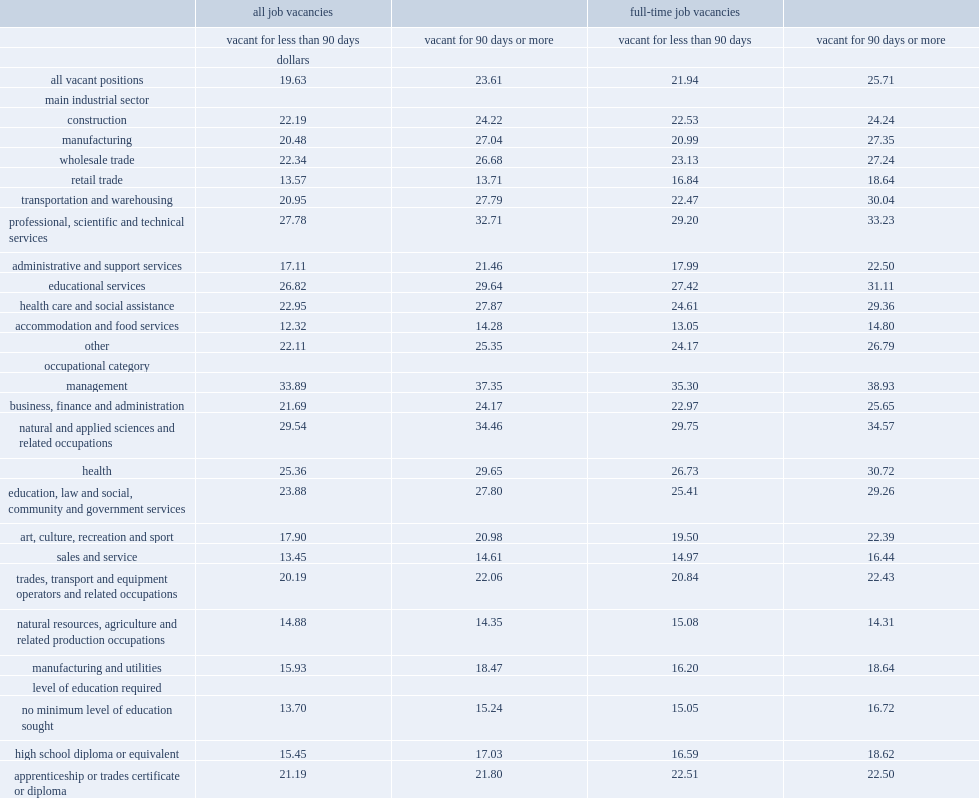In 2016, what is the difference between employers were willing to pay $23.61 per hour on average to fill long-term vacancies and those with $19.63 for positions vacant for less than 90 days? 0.202751. In 2016, list top two vacant positions among main industrial sectors that have the largest gaps between long-term job vacancies and other job vacancies. Transportation and warehousing manufacturing. For having the largest gaps between long-term job vacancies and other job vacancies, which sectors ranked fourth and sixth, respectively? Health care and social assistance professional, scientific and technical services. 